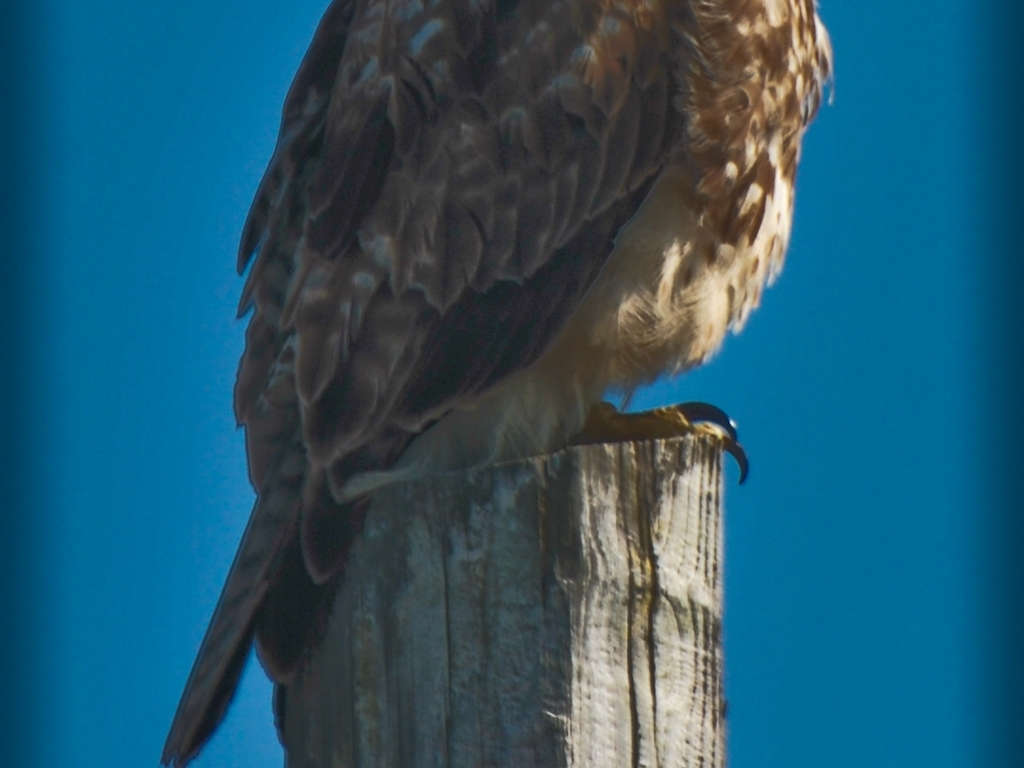What kind of bird is pictured in this image? The bird in the image is challenging to definitively identify due to the angle and focus, but it resembles a bird of prey, possibly a hawk, judging by its hooked beak and the pattern of its feathers. Can you determine what the bird might be doing? The bird's posture, with its gaze directed downwards, suggests that it may be observing the ground, likely scanning for potential prey or perhaps simply resting while perched atop the post. 